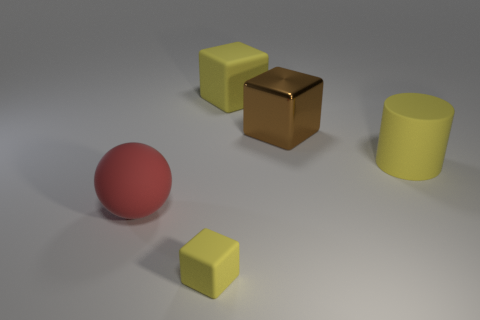Add 3 matte balls. How many objects exist? 8 Subtract all cylinders. How many objects are left? 4 Add 4 large red metallic cylinders. How many large red metallic cylinders exist? 4 Subtract 0 yellow balls. How many objects are left? 5 Subtract all tiny red cylinders. Subtract all tiny yellow rubber objects. How many objects are left? 4 Add 2 red balls. How many red balls are left? 3 